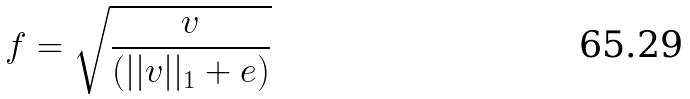<formula> <loc_0><loc_0><loc_500><loc_500>f = \sqrt { \frac { v } { ( | | v | | _ { 1 } + e ) } }</formula> 